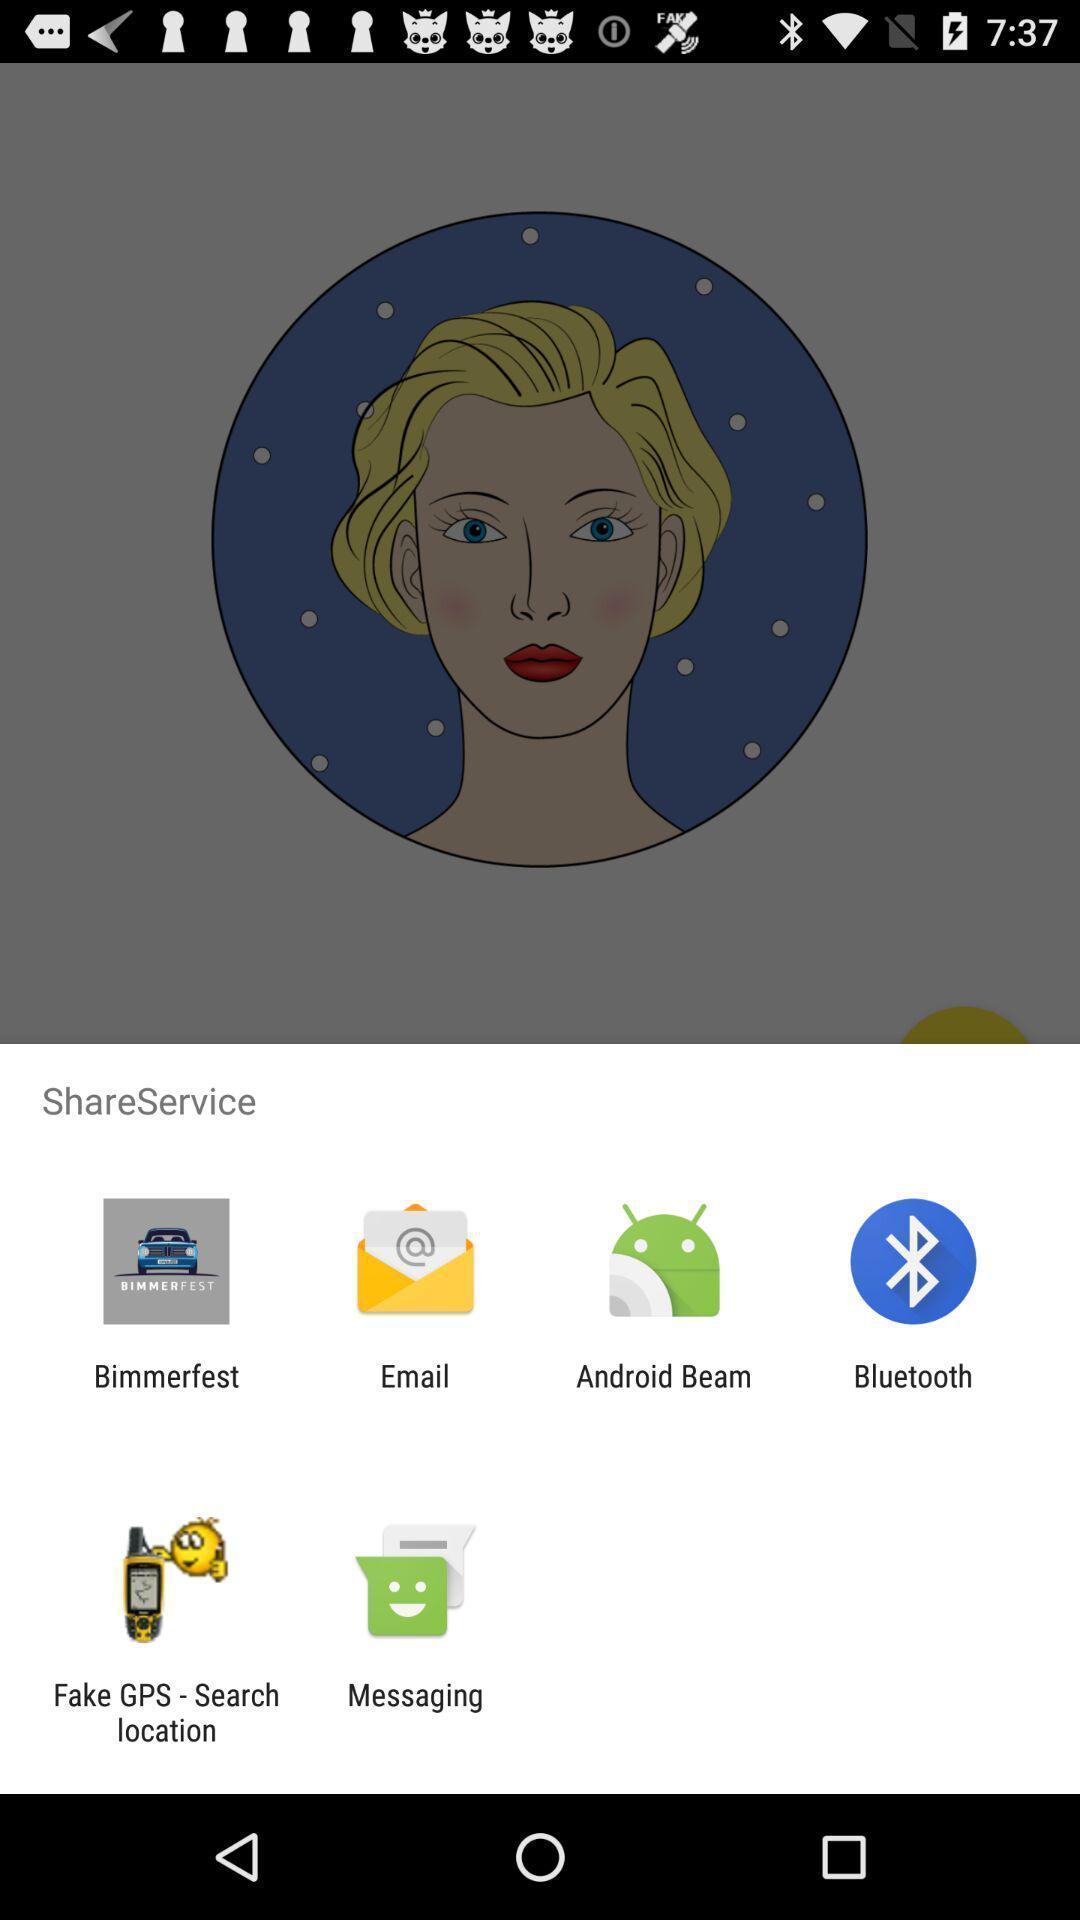Please provide a description for this image. Pop up showing various apps. 